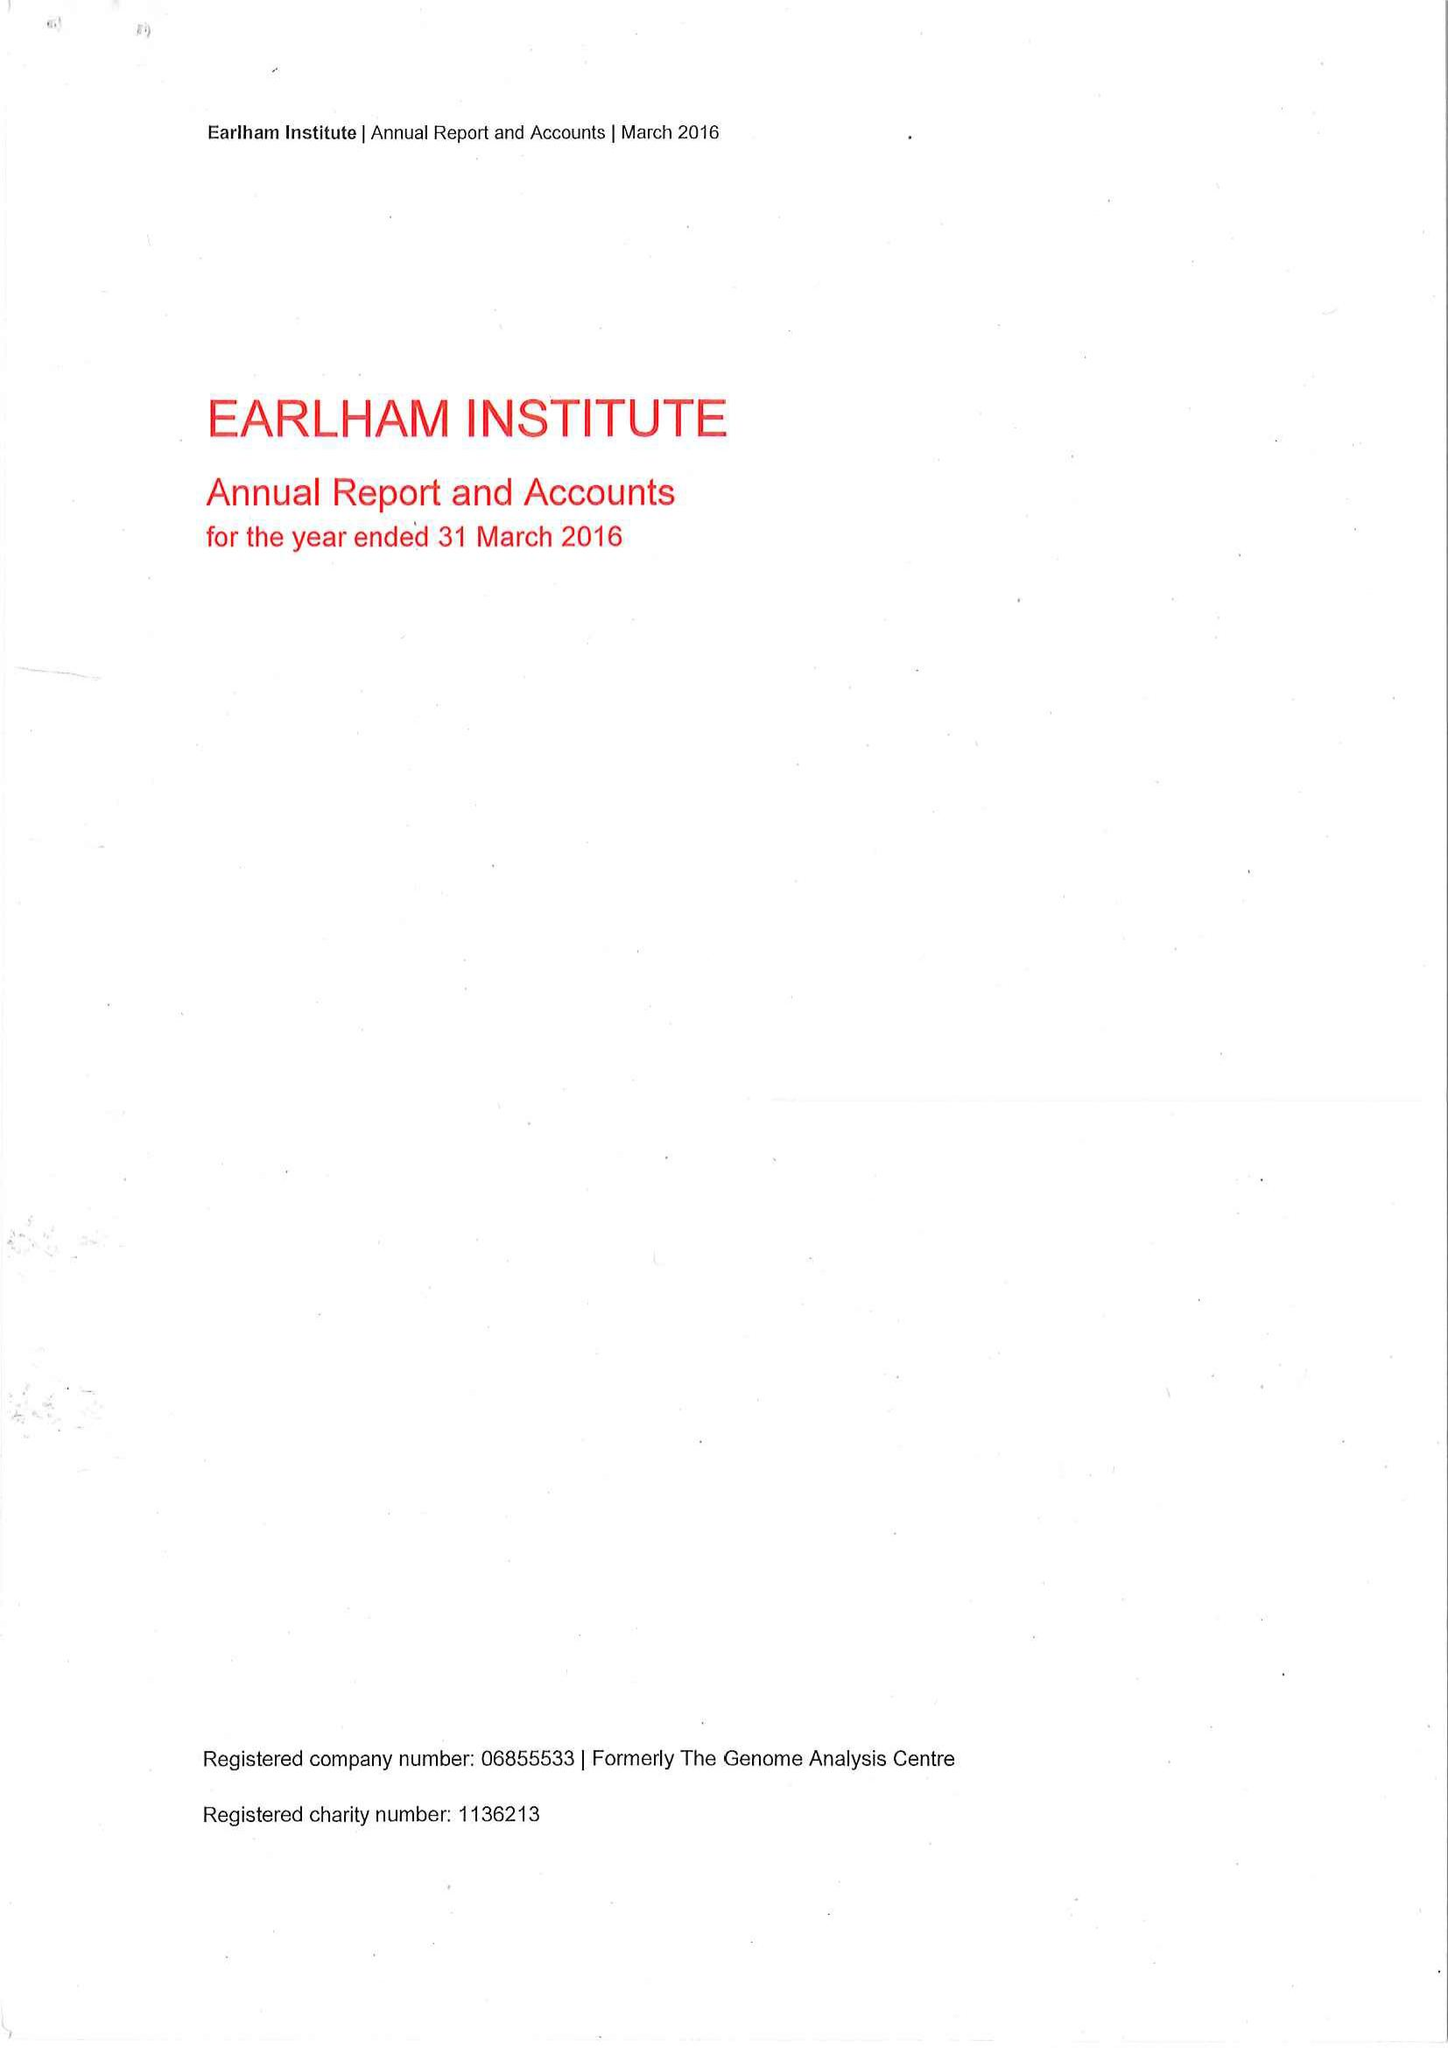What is the value for the report_date?
Answer the question using a single word or phrase. 2016-03-31 